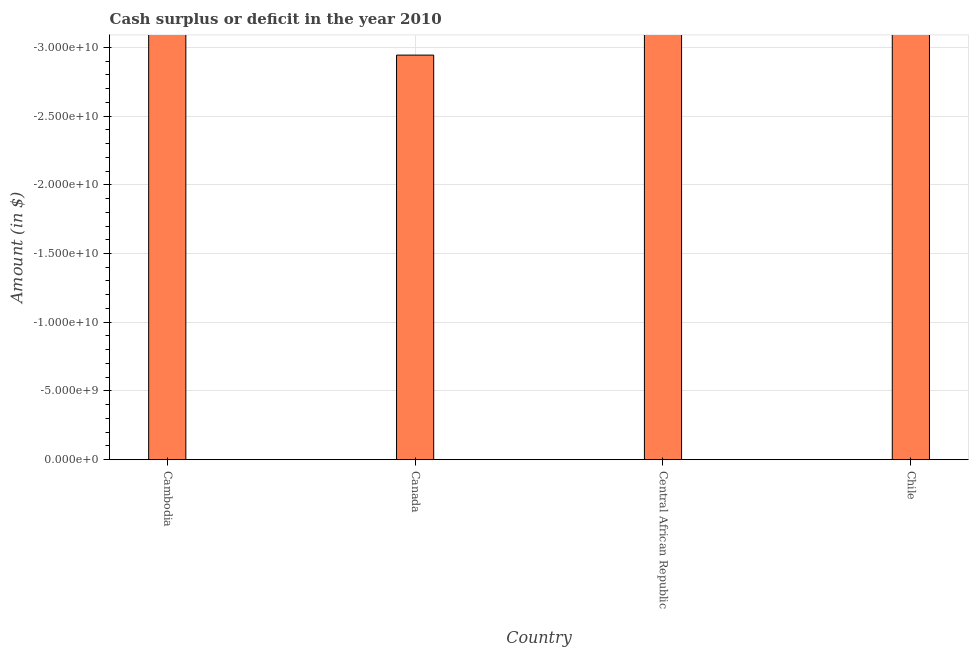What is the title of the graph?
Give a very brief answer. Cash surplus or deficit in the year 2010. What is the label or title of the X-axis?
Your answer should be compact. Country. What is the label or title of the Y-axis?
Your answer should be compact. Amount (in $). Across all countries, what is the minimum cash surplus or deficit?
Give a very brief answer. 0. In how many countries, is the cash surplus or deficit greater than the average cash surplus or deficit taken over all countries?
Keep it short and to the point. 0. How many countries are there in the graph?
Your answer should be very brief. 4. What is the difference between two consecutive major ticks on the Y-axis?
Provide a short and direct response. 5.00e+09. 